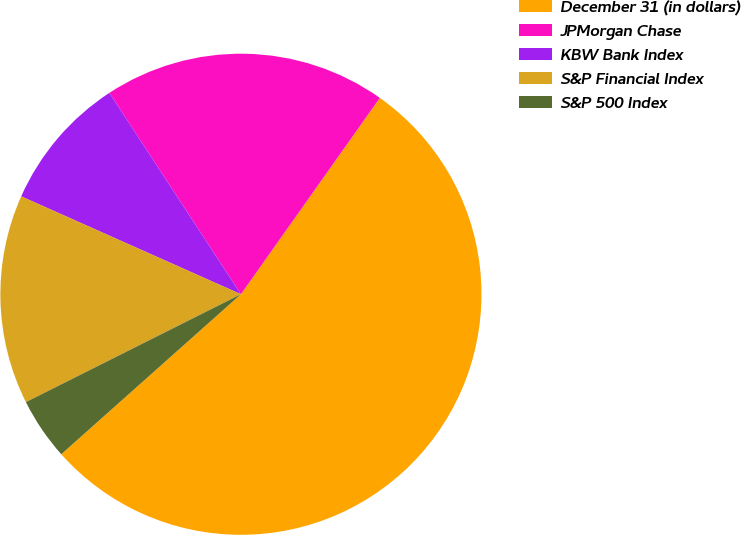Convert chart to OTSL. <chart><loc_0><loc_0><loc_500><loc_500><pie_chart><fcel>December 31 (in dollars)<fcel>JPMorgan Chase<fcel>KBW Bank Index<fcel>S&P Financial Index<fcel>S&P 500 Index<nl><fcel>53.62%<fcel>19.01%<fcel>9.12%<fcel>14.07%<fcel>4.18%<nl></chart> 